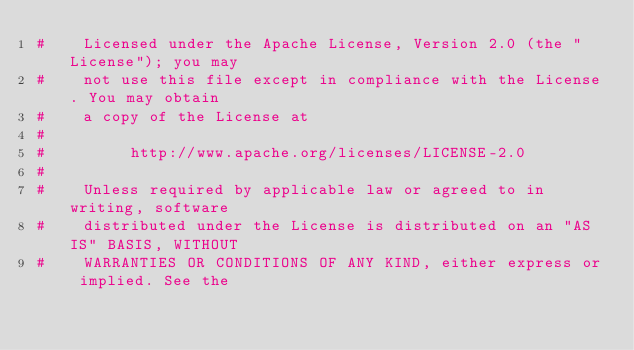Convert code to text. <code><loc_0><loc_0><loc_500><loc_500><_Python_>#    Licensed under the Apache License, Version 2.0 (the "License"); you may
#    not use this file except in compliance with the License. You may obtain
#    a copy of the License at
#
#         http://www.apache.org/licenses/LICENSE-2.0
#
#    Unless required by applicable law or agreed to in writing, software
#    distributed under the License is distributed on an "AS IS" BASIS, WITHOUT
#    WARRANTIES OR CONDITIONS OF ANY KIND, either express or implied. See the</code> 